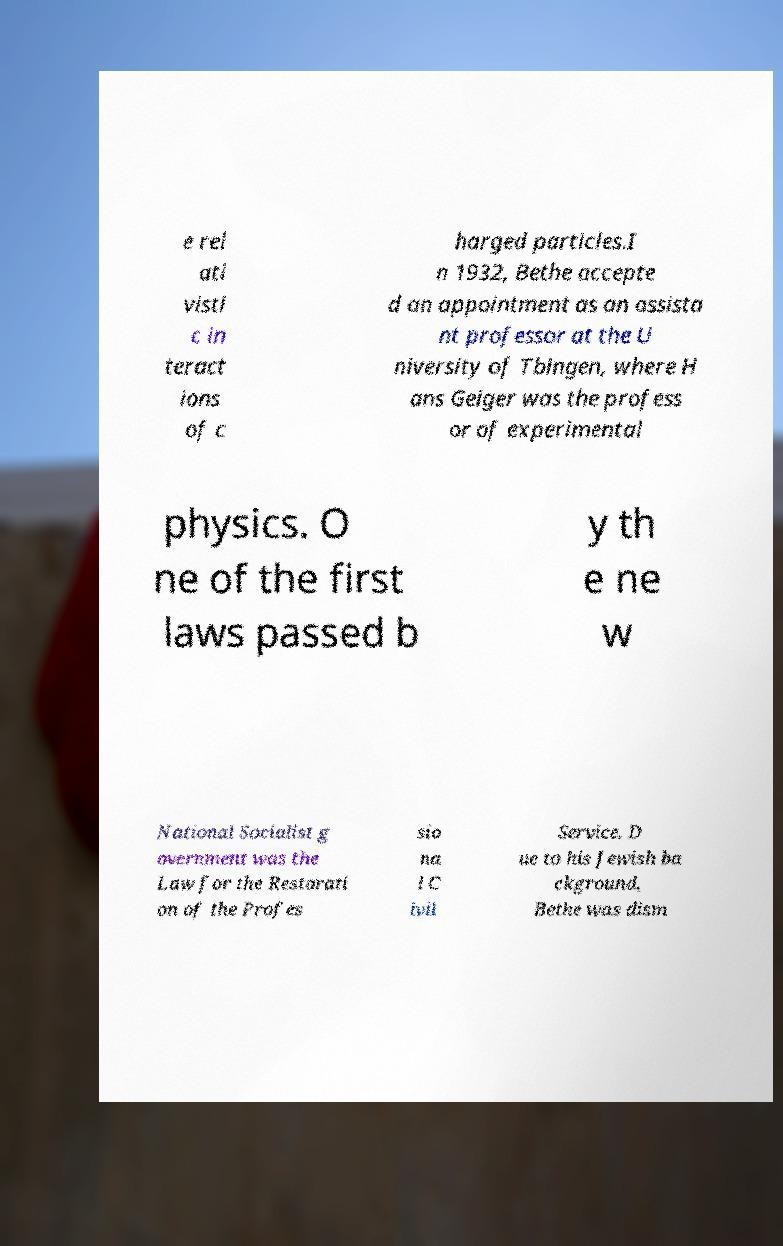There's text embedded in this image that I need extracted. Can you transcribe it verbatim? e rel ati visti c in teract ions of c harged particles.I n 1932, Bethe accepte d an appointment as an assista nt professor at the U niversity of Tbingen, where H ans Geiger was the profess or of experimental physics. O ne of the first laws passed b y th e ne w National Socialist g overnment was the Law for the Restorati on of the Profes sio na l C ivil Service. D ue to his Jewish ba ckground, Bethe was dism 